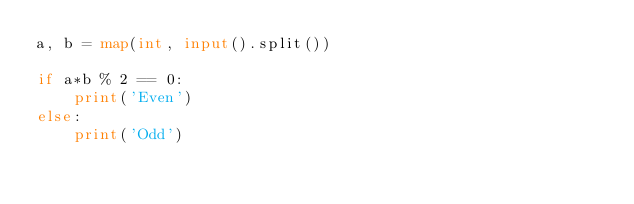Convert code to text. <code><loc_0><loc_0><loc_500><loc_500><_Python_>a, b = map(int, input().split())

if a*b % 2 == 0:
    print('Even')
else:
    print('Odd')</code> 